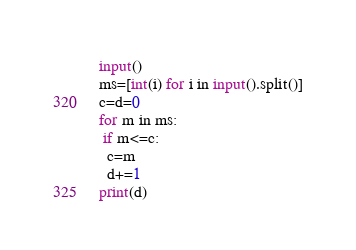Convert code to text. <code><loc_0><loc_0><loc_500><loc_500><_Python_>input()
ms=[int(i) for i in input().split()]
c=d=0
for m in ms:
 if m<=c:
  c=m
  d+=1
print(d)</code> 